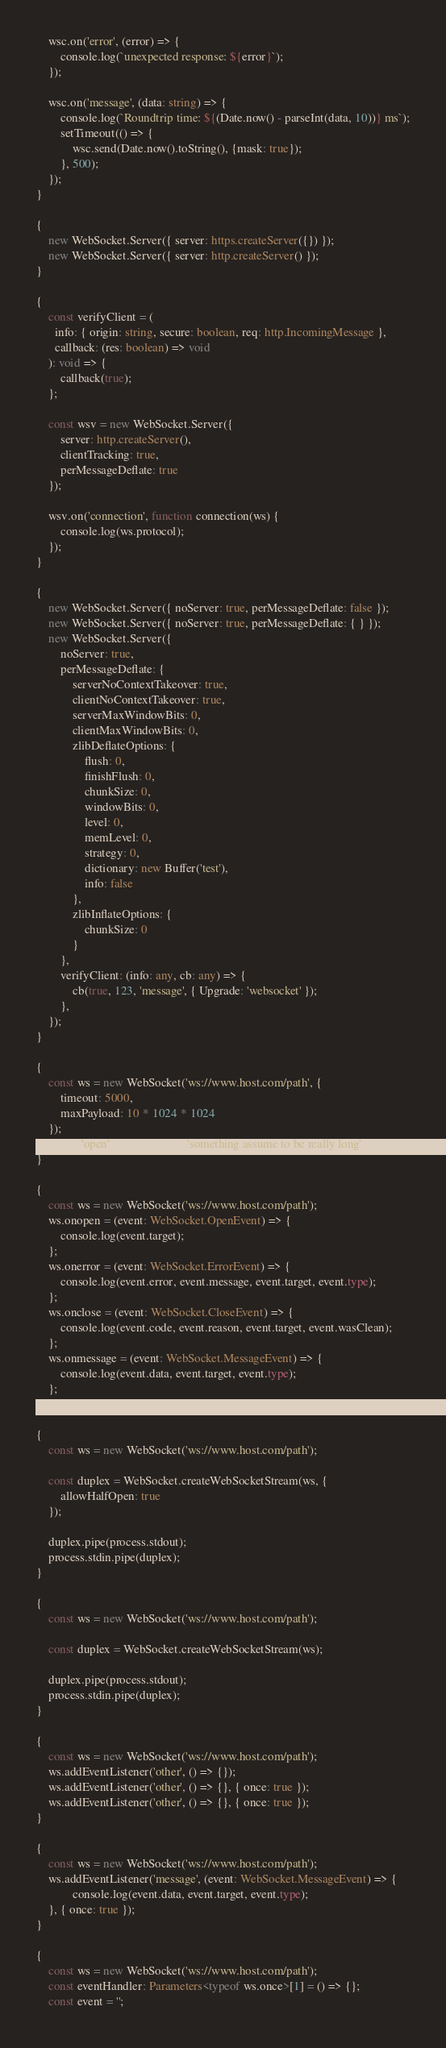<code> <loc_0><loc_0><loc_500><loc_500><_TypeScript_>    wsc.on('error', (error) => {
        console.log(`unexpected response: ${error}`);
    });

    wsc.on('message', (data: string) => {
        console.log(`Roundtrip time: ${(Date.now() - parseInt(data, 10))} ms`);
        setTimeout(() => {
            wsc.send(Date.now().toString(), {mask: true});
        }, 500);
    });
}

{
    new WebSocket.Server({ server: https.createServer({}) });
    new WebSocket.Server({ server: http.createServer() });
}

{
    const verifyClient = (
      info: { origin: string, secure: boolean, req: http.IncomingMessage },
      callback: (res: boolean) => void
    ): void => {
        callback(true);
    };

    const wsv = new WebSocket.Server({
        server: http.createServer(),
        clientTracking: true,
        perMessageDeflate: true
    });

    wsv.on('connection', function connection(ws) {
        console.log(ws.protocol);
    });
}

{
    new WebSocket.Server({ noServer: true, perMessageDeflate: false });
    new WebSocket.Server({ noServer: true, perMessageDeflate: { } });
    new WebSocket.Server({
        noServer: true,
        perMessageDeflate: {
            serverNoContextTakeover: true,
            clientNoContextTakeover: true,
            serverMaxWindowBits: 0,
            clientMaxWindowBits: 0,
            zlibDeflateOptions: {
                flush: 0,
                finishFlush: 0,
                chunkSize: 0,
                windowBits: 0,
                level: 0,
                memLevel: 0,
                strategy: 0,
                dictionary: new Buffer('test'),
                info: false
            },
            zlibInflateOptions: {
                chunkSize: 0
            }
        },
        verifyClient: (info: any, cb: any) => {
            cb(true, 123, 'message', { Upgrade: 'websocket' });
        },
    });
}

{
    const ws = new WebSocket('ws://www.host.com/path', {
        timeout: 5000,
        maxPayload: 10 * 1024 * 1024
    });
    ws.on('open', () => ws.send('something assume to be really long'));
}

{
    const ws = new WebSocket('ws://www.host.com/path');
    ws.onopen = (event: WebSocket.OpenEvent) => {
        console.log(event.target);
    };
    ws.onerror = (event: WebSocket.ErrorEvent) => {
        console.log(event.error, event.message, event.target, event.type);
    };
    ws.onclose = (event: WebSocket.CloseEvent) => {
        console.log(event.code, event.reason, event.target, event.wasClean);
    };
    ws.onmessage = (event: WebSocket.MessageEvent) => {
        console.log(event.data, event.target, event.type);
    };
}

{
    const ws = new WebSocket('ws://www.host.com/path');

    const duplex = WebSocket.createWebSocketStream(ws, {
        allowHalfOpen: true
    });

    duplex.pipe(process.stdout);
    process.stdin.pipe(duplex);
}

{
    const ws = new WebSocket('ws://www.host.com/path');

    const duplex = WebSocket.createWebSocketStream(ws);

    duplex.pipe(process.stdout);
    process.stdin.pipe(duplex);
}

{
    const ws = new WebSocket('ws://www.host.com/path');
    ws.addEventListener('other', () => {});
    ws.addEventListener('other', () => {}, { once: true });
    ws.addEventListener('other', () => {}, { once: true });
}

{
    const ws = new WebSocket('ws://www.host.com/path');
    ws.addEventListener('message', (event: WebSocket.MessageEvent) => {
            console.log(event.data, event.target, event.type);
    }, { once: true });
}

{
    const ws = new WebSocket('ws://www.host.com/path');
    const eventHandler: Parameters<typeof ws.once>[1] = () => {};
    const event = '';</code> 